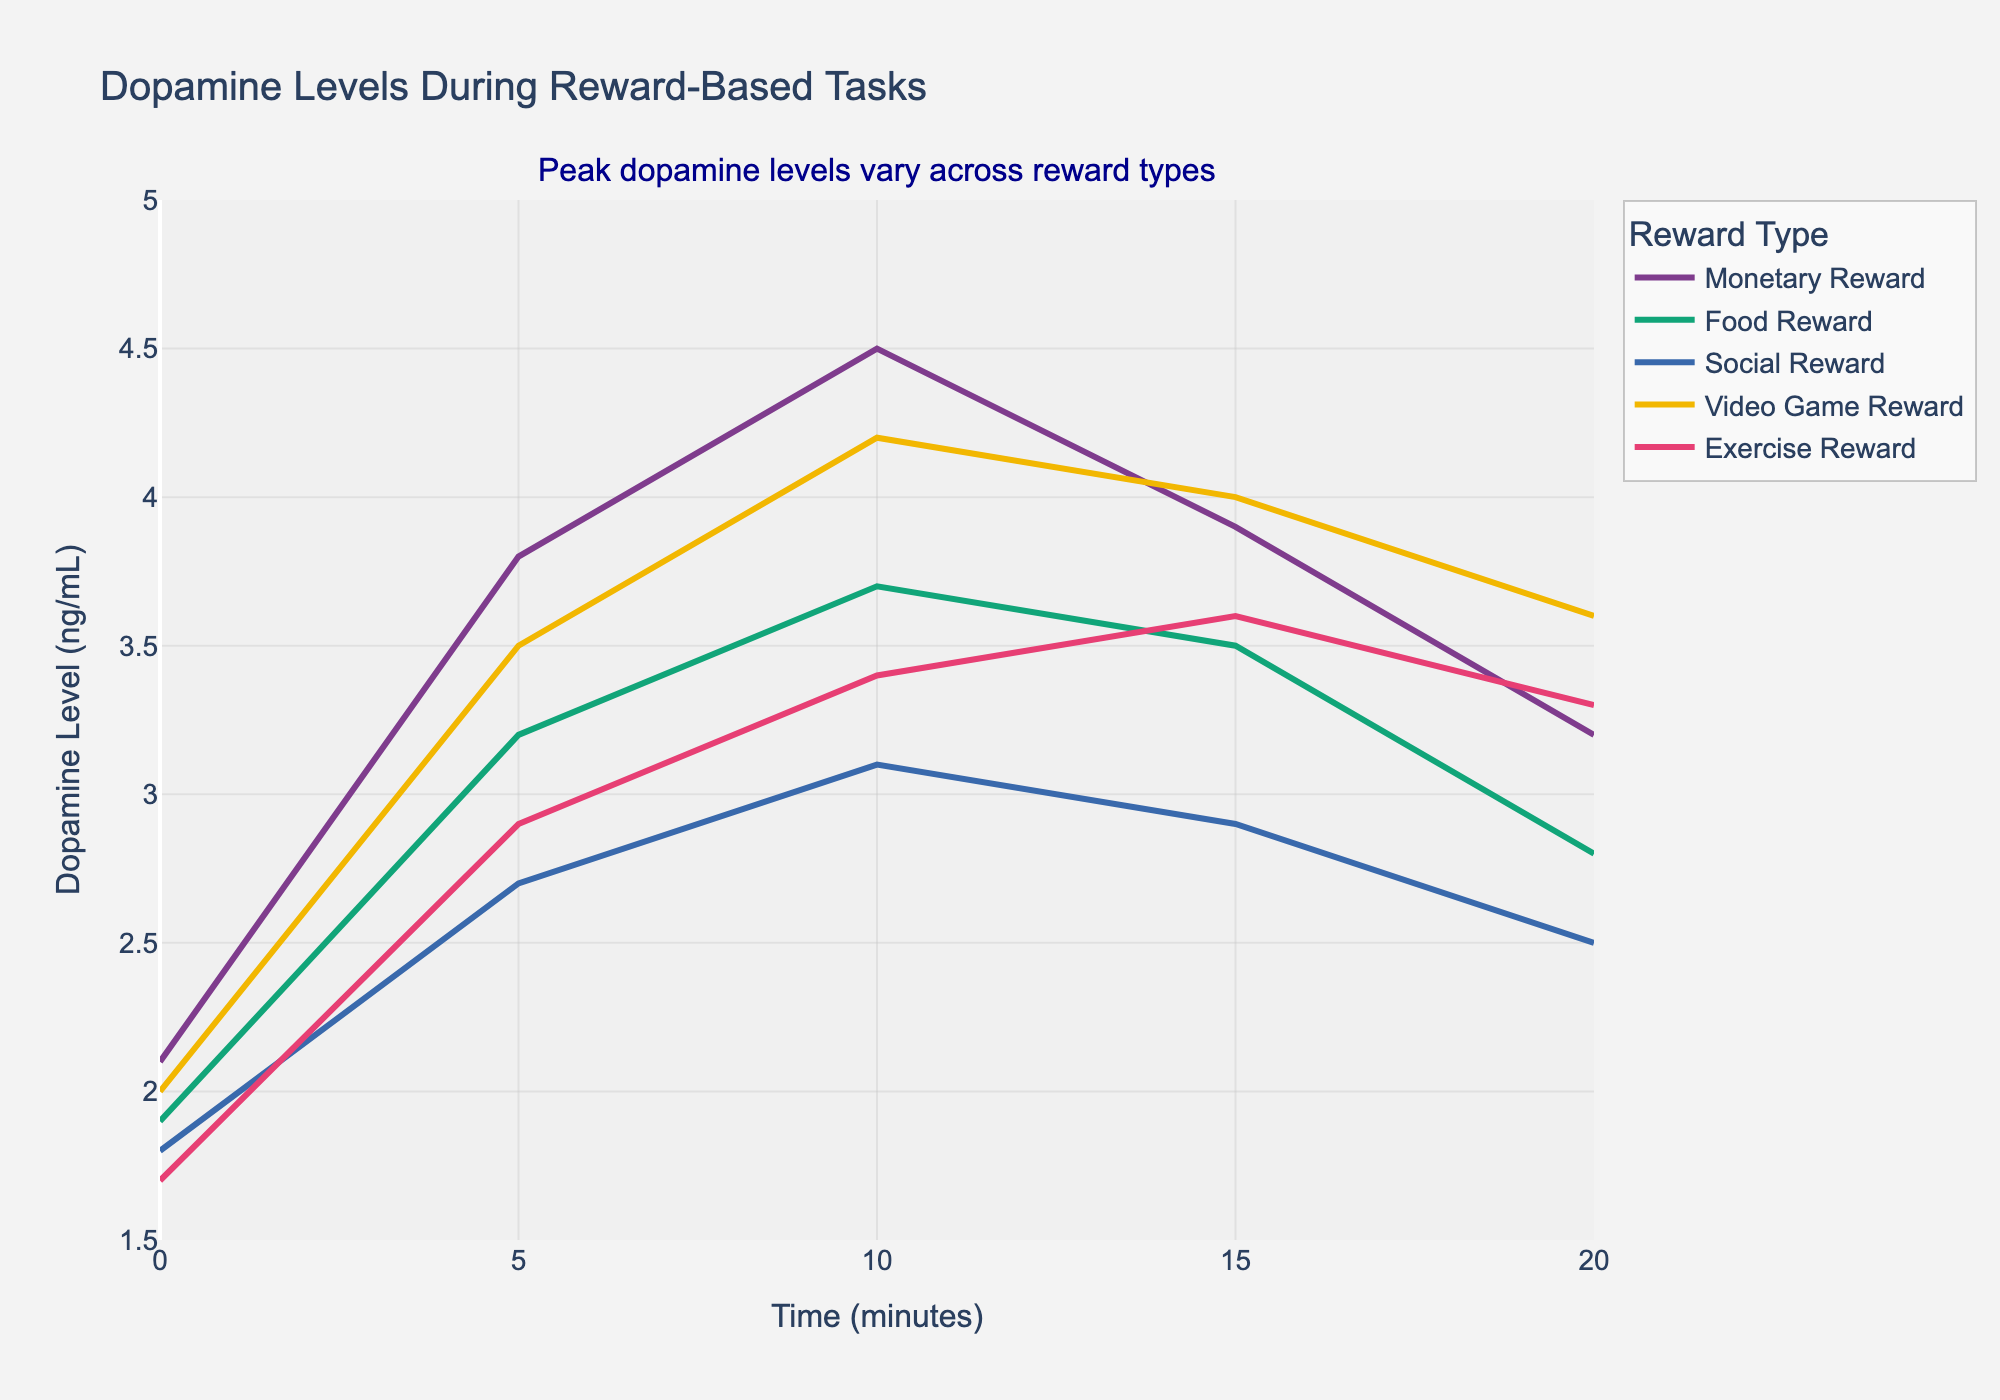What is the trend in dopamine levels for the Monetary Reward task over time? Dopamine levels increase from 2.1 ng/mL at 0 minutes to a peak of 4.5 ng/mL at 10 minutes, then decrease to 3.2 ng/mL at 20 minutes.
Answer: Increase then decrease Which reward type shows the highest peak dopamine level? The highest peak dopamine level is observed in the Video Game Reward task at 10 minutes with a value of 4.2 ng/mL.
Answer: Video Game Reward Compare the dopamine levels of Food Reward and Social Reward at 10 minutes. Which one is higher, and by how much? At 10 minutes, Food Reward has a dopamine level of 3.7 ng/mL, while Social Reward has 3.1 ng/mL. The difference is 3.7 - 3.1 = 0.6 ng/mL.
Answer: Food Reward by 0.6 ng/mL Which reward type shows the smallest increase in dopamine levels from 0 to 5 minutes? Social Reward shows the smallest increase in dopamine levels from 1.8 ng/mL to 2.7 ng/mL, an increase of 0.9 ng/mL.
Answer: Social Reward What is the average dopamine level for the Exercise Reward task over the 20 minutes? The dopamine levels for Exercise Reward are 1.7, 2.9, 3.4, 3.6, and 3.3 ng/mL. The sum is 1.7 + 2.9 + 3.4 + 3.6 + 3.3 = 14.9 ng/mL. The average is 14.9 / 5 = 2.98 ng/mL.
Answer: 2.98 ng/mL How do dopamine levels at 20 minutes for the Social Reward task compare to those at 0 minutes? At 0 minutes, dopamine levels for Social Reward are 1.8 ng/mL and at 20 minutes they are 2.5 ng/mL, indicating an increase of 0.7 ng/mL.
Answer: Increased by 0.7 ng/mL Which reward type maintains the highest dopamine levels consistently from 5 to 15 minutes? Video Game Reward maintains the highest dopamine levels consistently from 5 minutes (3.5 ng/mL) to 15 minutes (4.0 ng/mL).
Answer: Video Game Reward Do any of the tasks show a continuous increase in dopamine levels over the entire 20 minutes? All tasks show some periods of increase and decrease in dopamine levels; no task shows a continuous increase over the entire 20 minutes.
Answer: No At which time point does the Video Game Reward task have the greatest difference in dopamine levels compared to the Social Reward task? The greatest difference between Video Game Reward and Social Reward occurs at 10 minutes: Video Game Reward is 4.2 ng/mL and Social Reward is 3.1 ng/mL, a difference of 4.2 - 3.1 = 1.1 ng/mL.
Answer: 10 minutes What is the range of dopamine levels observed for the Monetary Reward task? The dopamine levels for the Monetary Reward task range from a minimum of 2.1 ng/mL at 0 minutes to a maximum of 4.5 ng/mL at 10 minutes.
Answer: 2.1 to 4.5 ng/mL 